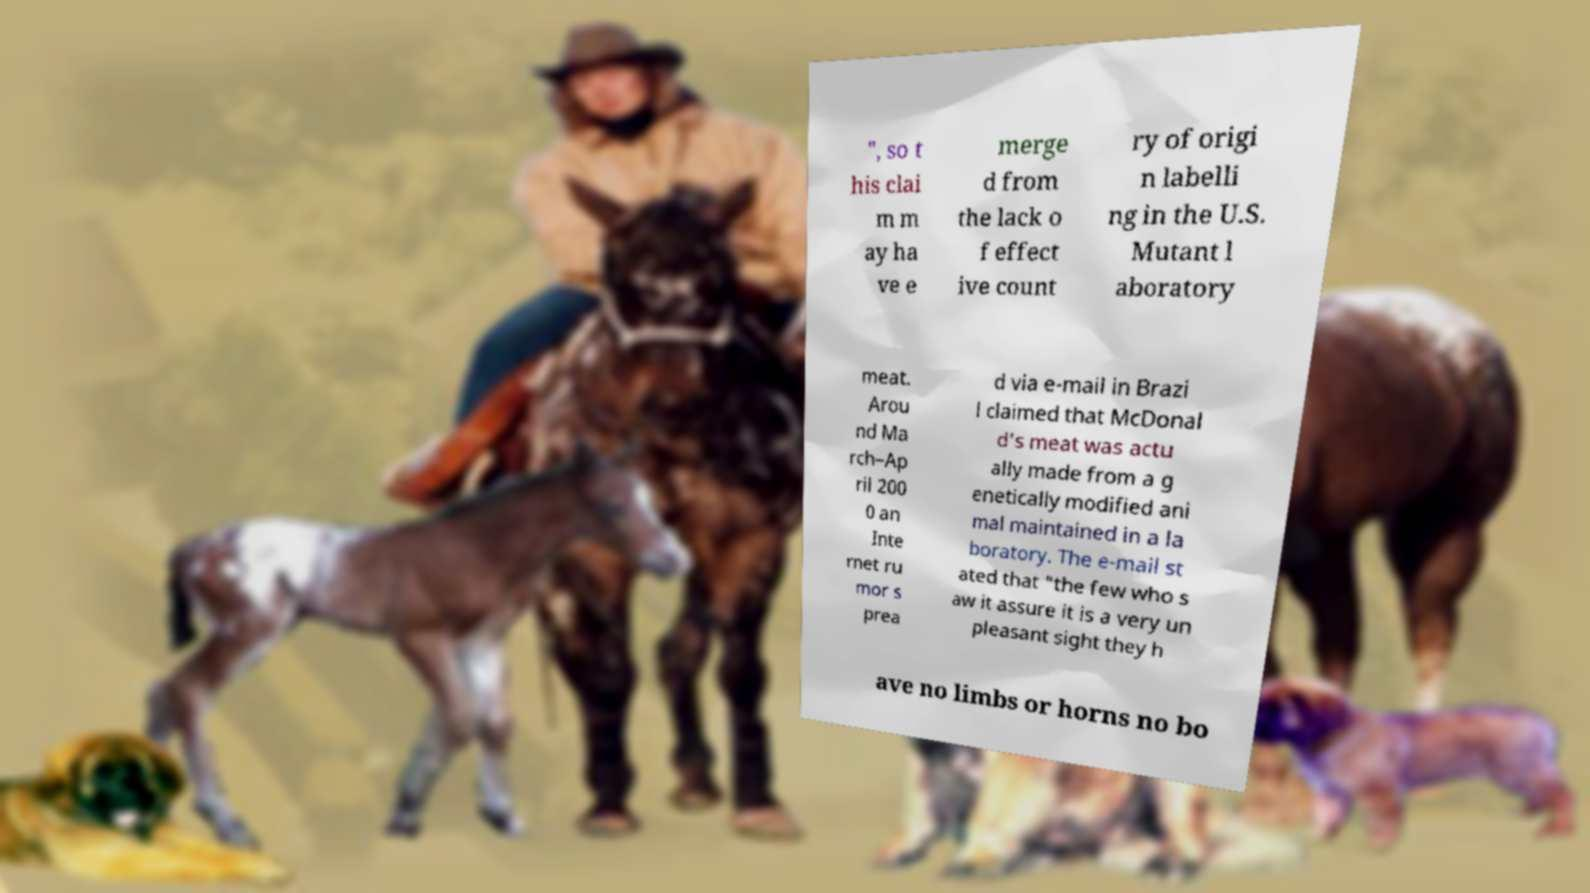There's text embedded in this image that I need extracted. Can you transcribe it verbatim? ", so t his clai m m ay ha ve e merge d from the lack o f effect ive count ry of origi n labelli ng in the U.S. Mutant l aboratory meat. Arou nd Ma rch–Ap ril 200 0 an Inte rnet ru mor s prea d via e-mail in Brazi l claimed that McDonal d's meat was actu ally made from a g enetically modified ani mal maintained in a la boratory. The e-mail st ated that "the few who s aw it assure it is a very un pleasant sight they h ave no limbs or horns no bo 